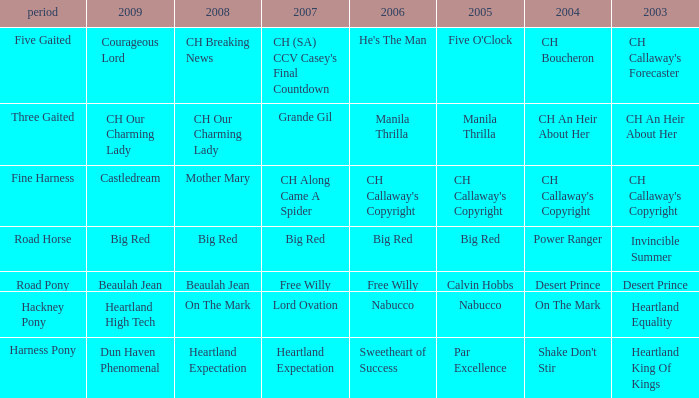Could you parse the entire table? {'header': ['period', '2009', '2008', '2007', '2006', '2005', '2004', '2003'], 'rows': [['Five Gaited', 'Courageous Lord', 'CH Breaking News', "CH (SA) CCV Casey's Final Countdown", "He's The Man", "Five O'Clock", 'CH Boucheron', "CH Callaway's Forecaster"], ['Three Gaited', 'CH Our Charming Lady', 'CH Our Charming Lady', 'Grande Gil', 'Manila Thrilla', 'Manila Thrilla', 'CH An Heir About Her', 'CH An Heir About Her'], ['Fine Harness', 'Castledream', 'Mother Mary', 'CH Along Came A Spider', "CH Callaway's Copyright", "CH Callaway's Copyright", "CH Callaway's Copyright", "CH Callaway's Copyright"], ['Road Horse', 'Big Red', 'Big Red', 'Big Red', 'Big Red', 'Big Red', 'Power Ranger', 'Invincible Summer'], ['Road Pony', 'Beaulah Jean', 'Beaulah Jean', 'Free Willy', 'Free Willy', 'Calvin Hobbs', 'Desert Prince', 'Desert Prince'], ['Hackney Pony', 'Heartland High Tech', 'On The Mark', 'Lord Ovation', 'Nabucco', 'Nabucco', 'On The Mark', 'Heartland Equality'], ['Harness Pony', 'Dun Haven Phenomenal', 'Heartland Expectation', 'Heartland Expectation', 'Sweetheart of Success', 'Par Excellence', "Shake Don't Stir", 'Heartland King Of Kings']]} In the context of our charming lady, what is the significance of the 2008 for the 2009 ch? CH Our Charming Lady. 